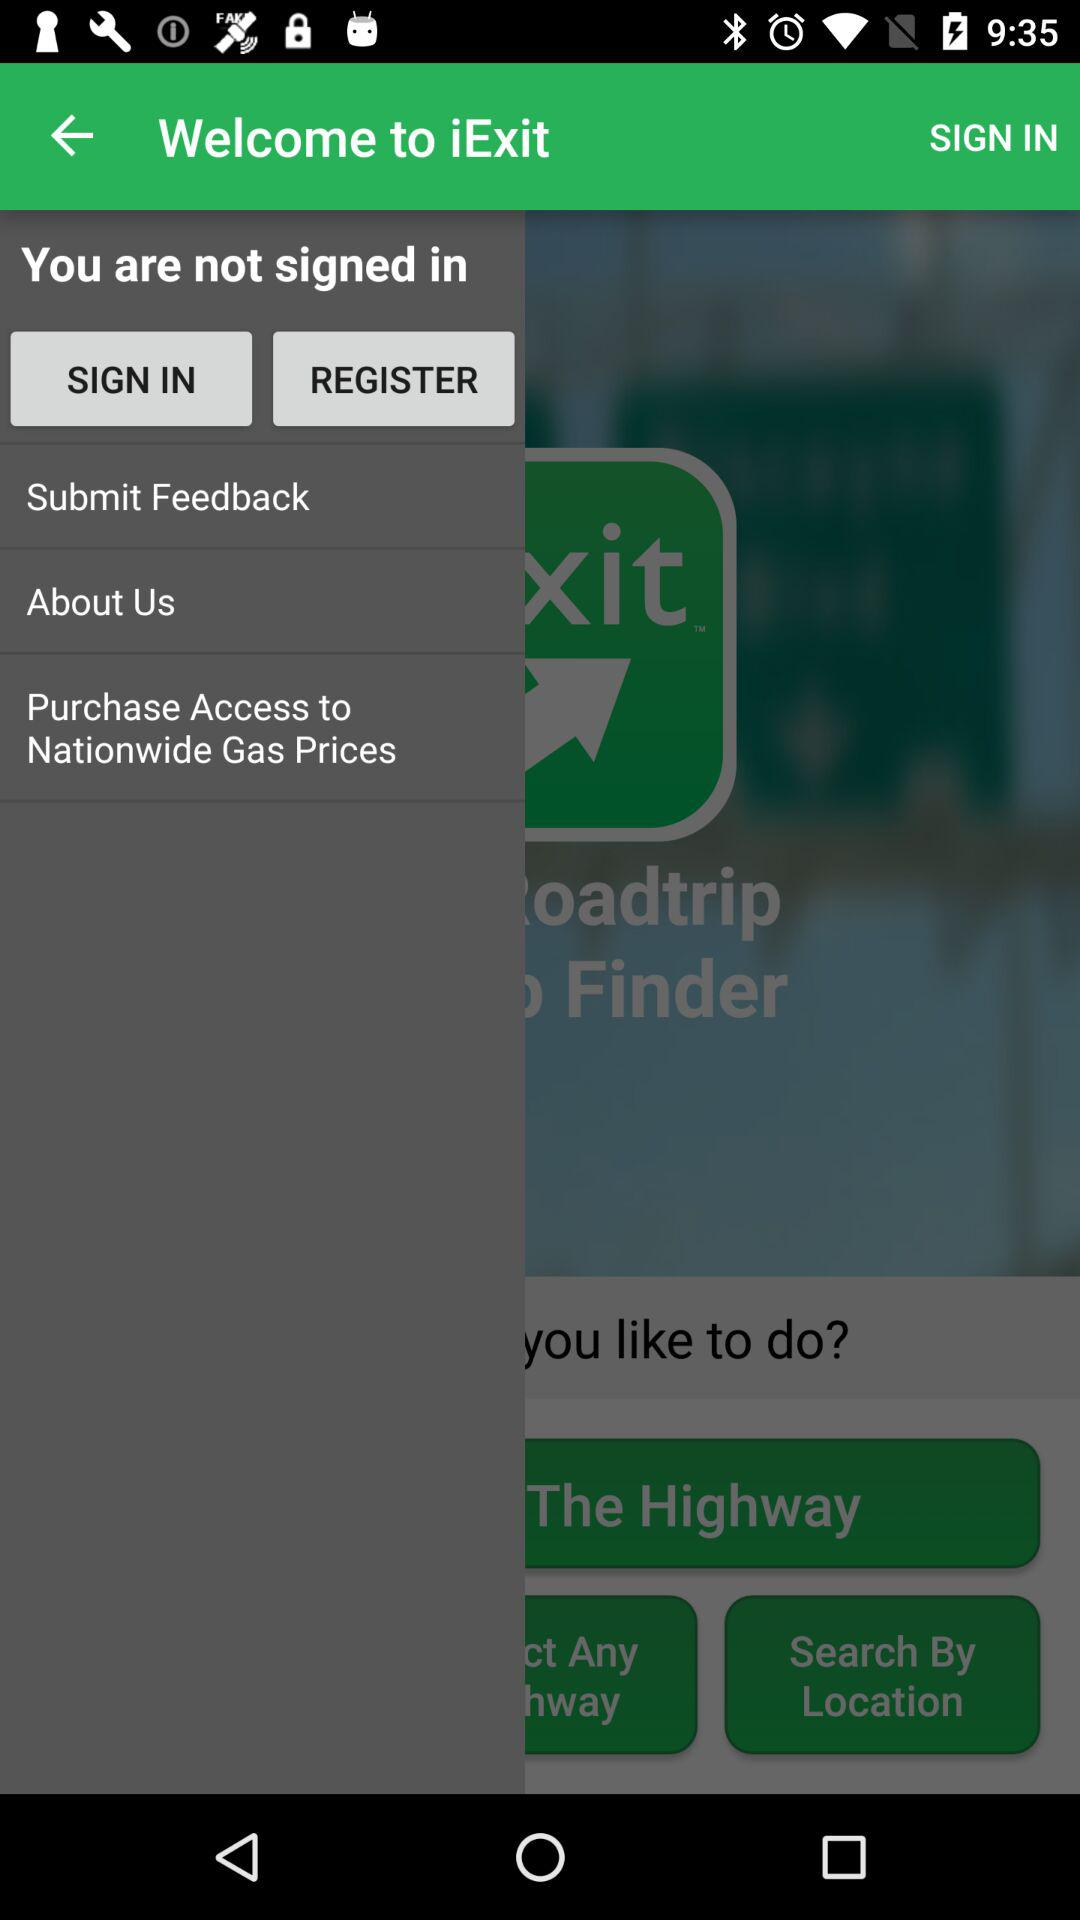What is the name of the application? The name of the application is "iExit". 